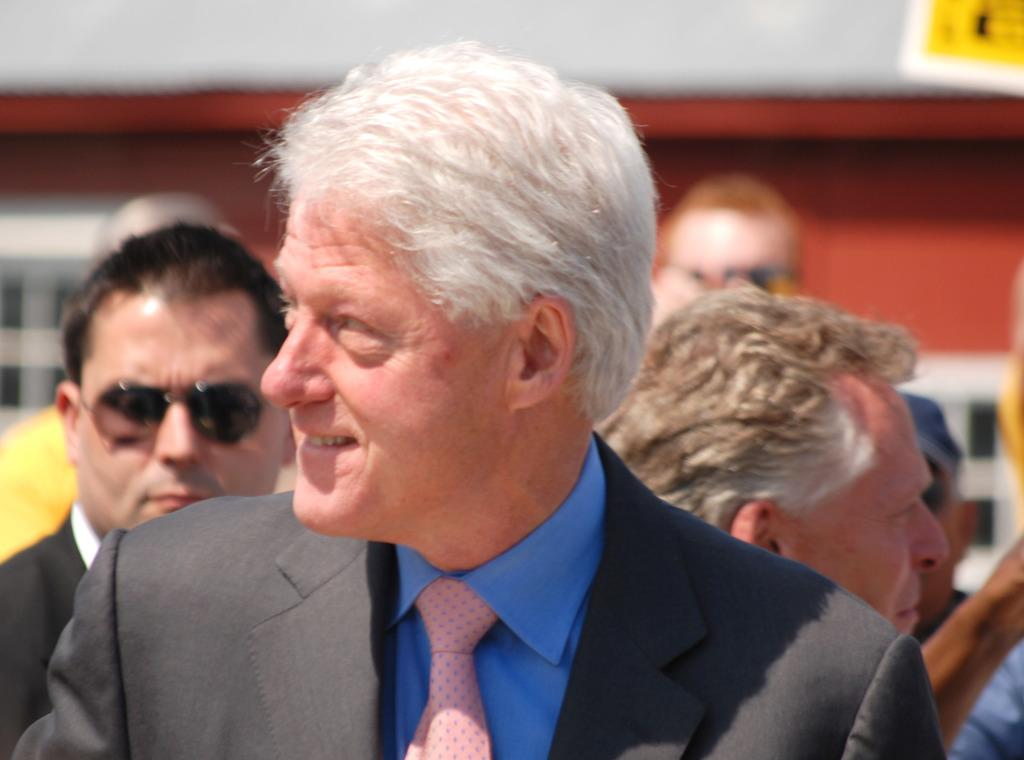How many people are in the image? There are multiple persons in the image. Can you describe the man in the front of the image? The man in the front of the image is wearing a tie, a blazer, and a blue shirt. What is the man in the front of the image doing? The man in the front of the image is smiling. Can you hear the man in the front of the image whistling in the image? There is: There is no indication of sound in the image, so it cannot be determined if the man is whistling or not. 